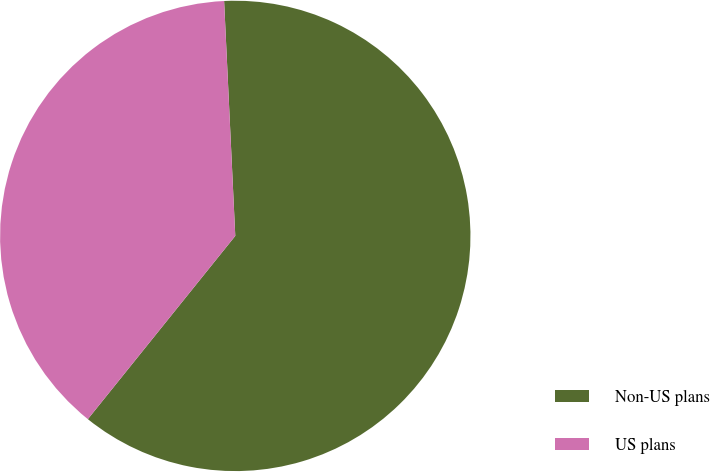Convert chart. <chart><loc_0><loc_0><loc_500><loc_500><pie_chart><fcel>Non-US plans<fcel>US plans<nl><fcel>61.54%<fcel>38.46%<nl></chart> 